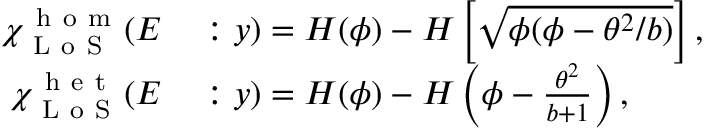<formula> <loc_0><loc_0><loc_500><loc_500>\begin{array} { r l } { \chi _ { L o S } ^ { h o m } ( E } & \colon y ) = H ( \phi ) - H \left [ \sqrt { \phi ( \phi - \theta ^ { 2 } / b ) } \right ] , } \\ { \chi _ { L o S } ^ { h e t } ( E } & \colon y ) = H ( \phi ) - H \left ( \phi - \frac { \theta ^ { 2 } } { b + 1 } \right ) , } \end{array}</formula> 